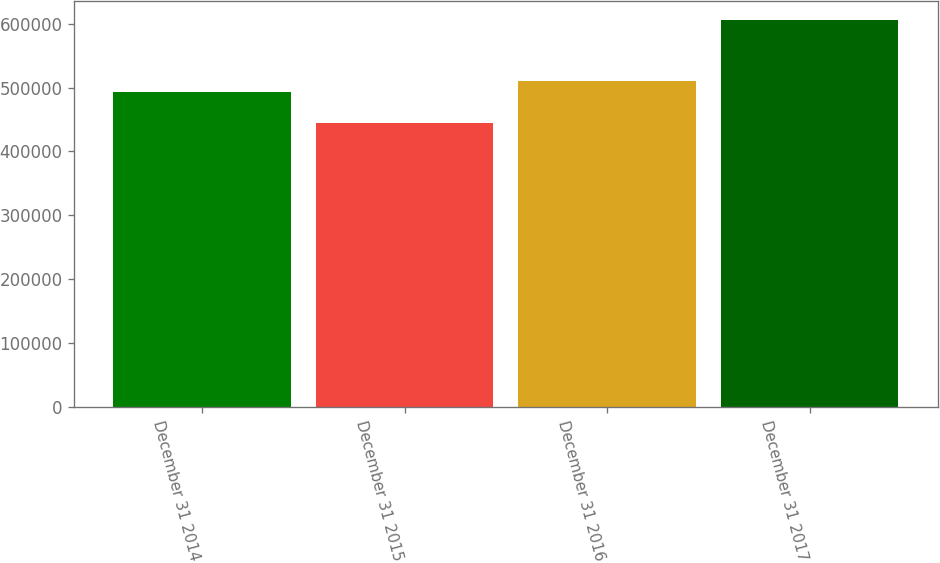Convert chart. <chart><loc_0><loc_0><loc_500><loc_500><bar_chart><fcel>December 31 2014<fcel>December 31 2015<fcel>December 31 2016<fcel>December 31 2017<nl><fcel>493694<fcel>444070<fcel>509828<fcel>605405<nl></chart> 